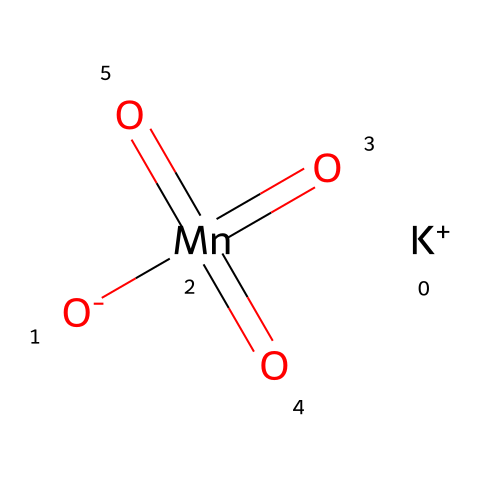What is the oxidation state of manganese in this compound? To find the oxidation state of manganese (Mn), we look at its connections in the chemical structure. The four oxygen groups are typically assigned an oxidation state of -2 each. Since there are four oxygen atoms contributing -8, we set up the equation: Mn + (-8) + 1 = 0 (the potassium ion contributes +1). Solving this gives Mn = +7.
Answer: +7 How many oxygen atoms are present in potassium permanganate? The chemical structure shows a total of four oxygen atoms connected to manganese. Counting them gives four.
Answer: 4 Is potassium permanganate an oxidizer? The structure indicates the presence of manganese in a high oxidation state (+7), which signifies it can accept electrons from other substances. This characteristic confirms its role as an oxidizer.
Answer: Yes What type of ion is present in potassium permanganate? The chemical structure includes a potassium ion (K+). This identifies the ionic nature of the compound since K+ is a cation that typically forms ionic bonds with anions such as permanganate (MnO4-).
Answer: Cation What is the geometric shape around the manganese atom in potassium permanganate? In the chemical structure, manganese surrounded by four oxygen atoms suggests a tetrahedral geometry because it is coordinated with four bonding pairs of electrons from the oxygen atoms.
Answer: Tetrahedral 